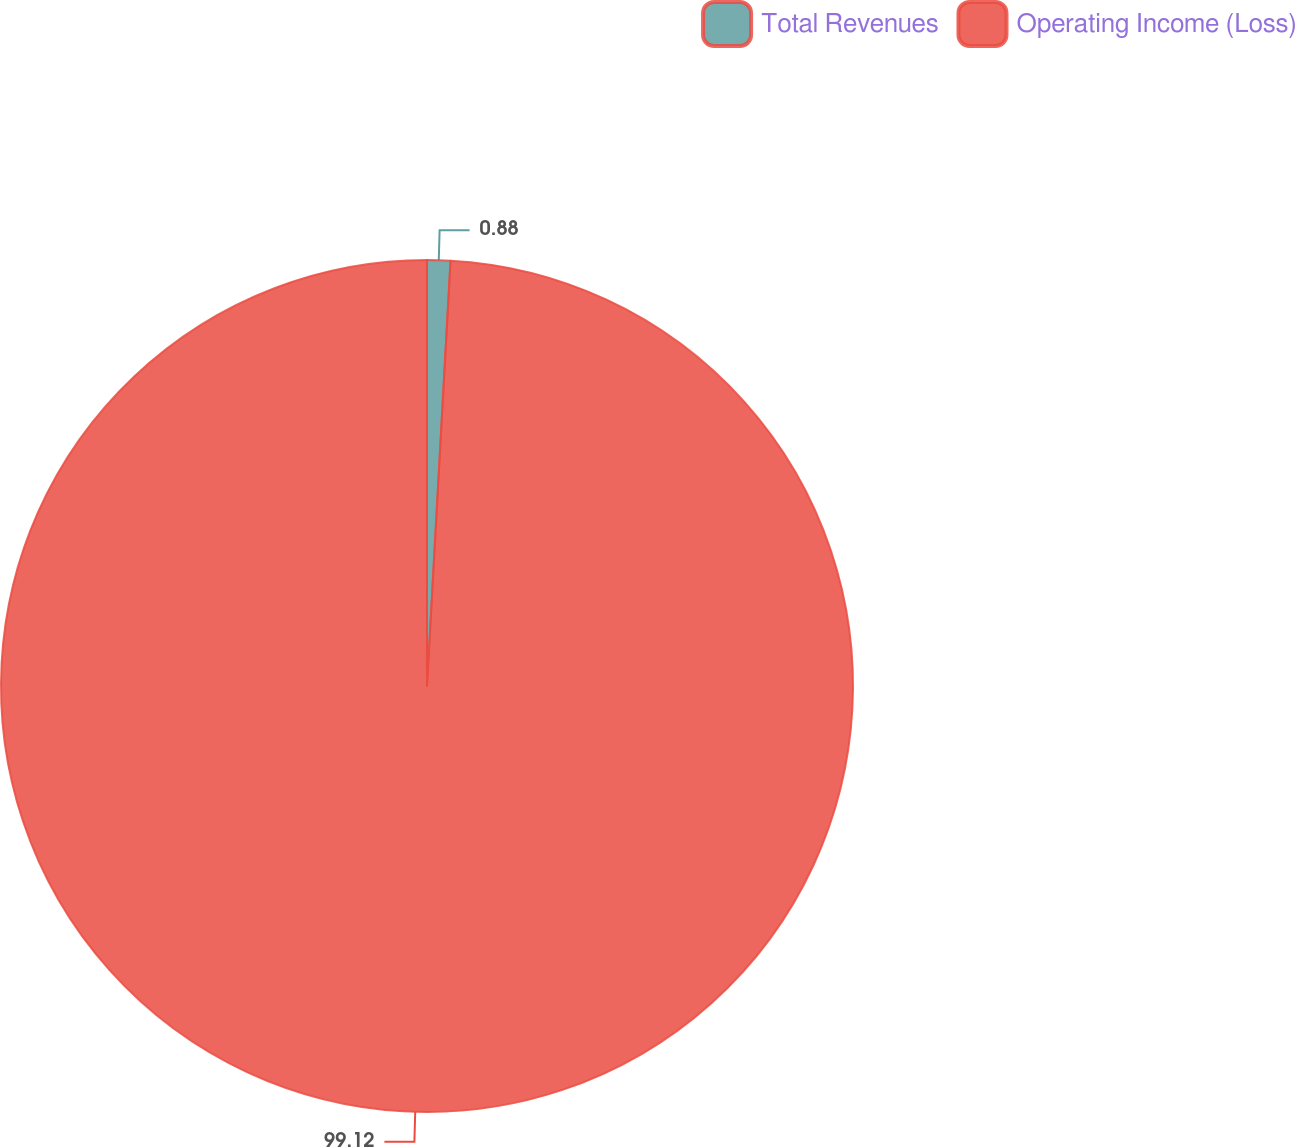Convert chart to OTSL. <chart><loc_0><loc_0><loc_500><loc_500><pie_chart><fcel>Total Revenues<fcel>Operating Income (Loss)<nl><fcel>0.88%<fcel>99.12%<nl></chart> 